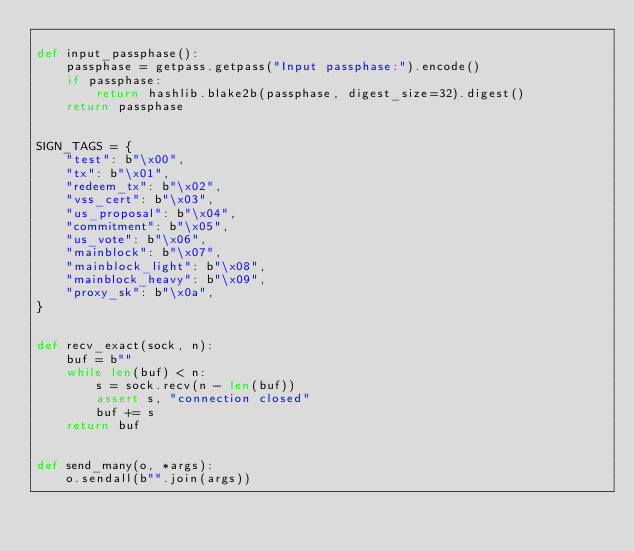<code> <loc_0><loc_0><loc_500><loc_500><_Python_>
def input_passphase():
    passphase = getpass.getpass("Input passphase:").encode()
    if passphase:
        return hashlib.blake2b(passphase, digest_size=32).digest()
    return passphase


SIGN_TAGS = {
    "test": b"\x00",
    "tx": b"\x01",
    "redeem_tx": b"\x02",
    "vss_cert": b"\x03",
    "us_proposal": b"\x04",
    "commitment": b"\x05",
    "us_vote": b"\x06",
    "mainblock": b"\x07",
    "mainblock_light": b"\x08",
    "mainblock_heavy": b"\x09",
    "proxy_sk": b"\x0a",
}


def recv_exact(sock, n):
    buf = b""
    while len(buf) < n:
        s = sock.recv(n - len(buf))
        assert s, "connection closed"
        buf += s
    return buf


def send_many(o, *args):
    o.sendall(b"".join(args))
</code> 